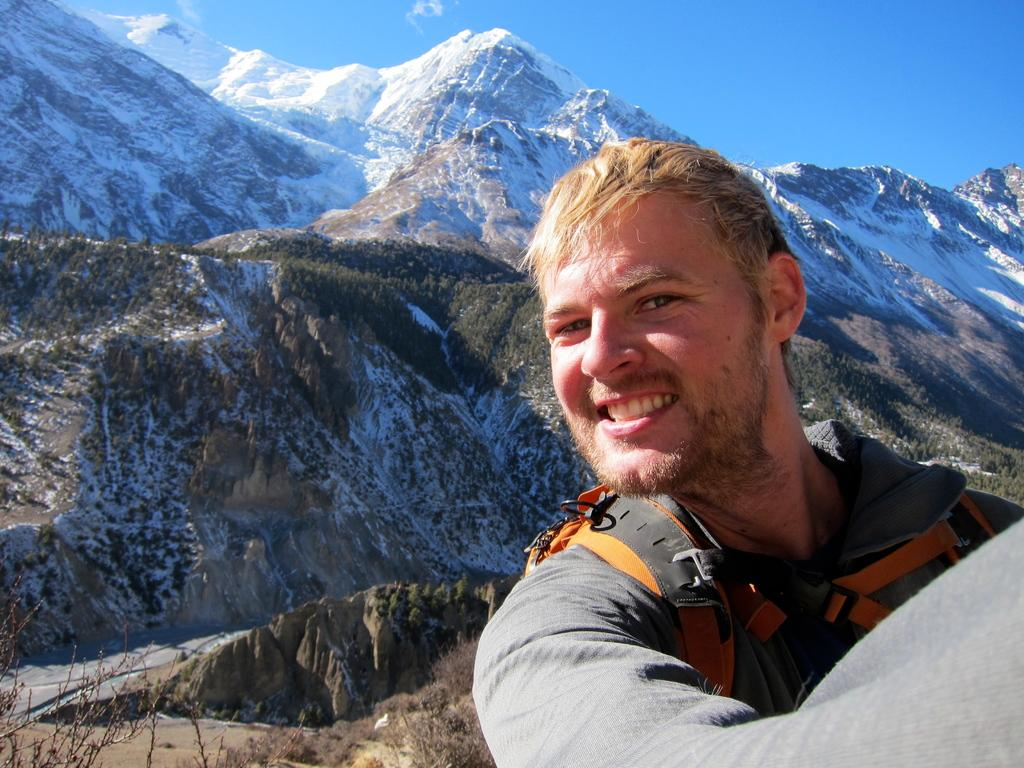What is the main subject of the image? There is a person in the image. What is the person wearing? The person is wearing a coat. What is the person carrying? The person is carrying a bag. What can be seen in the background of the image? There are mountains and trees in the background of the image. What is visible at the top of the image? The sky is visible at the top of the image. How many nails are visible in the image? There are no nails present in the image. What type of development can be seen in the background of the image? There is no development visible in the image; it features mountains and trees in the background. 